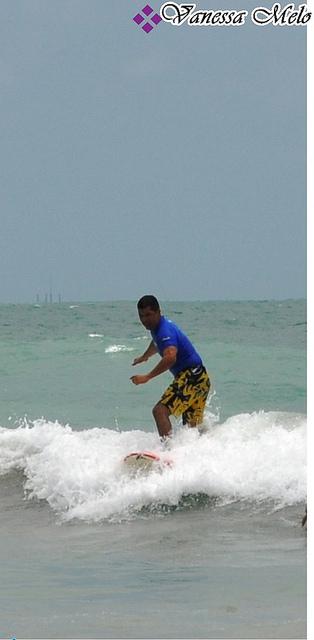Is anyone swimming?
Keep it brief. No. What color are the man's shorts?
Keep it brief. Yellow. What is the man riding?
Keep it brief. Surfboard. How deep of water is the man in?
Short answer required. Shallow. 